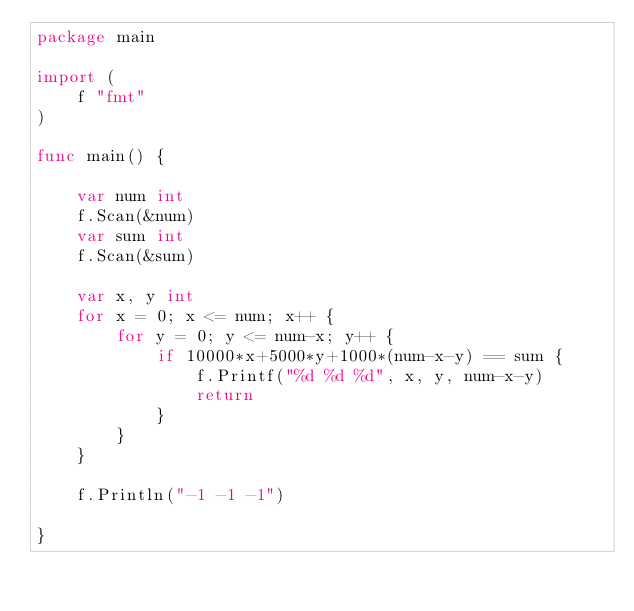Convert code to text. <code><loc_0><loc_0><loc_500><loc_500><_Go_>package main

import (
	f "fmt"
)

func main() {

	var num int
	f.Scan(&num)
	var sum int
	f.Scan(&sum)

	var x, y int
	for x = 0; x <= num; x++ {
		for y = 0; y <= num-x; y++ {
			if 10000*x+5000*y+1000*(num-x-y) == sum {
				f.Printf("%d %d %d", x, y, num-x-y)
				return
			}
		}
	}

	f.Println("-1 -1 -1")

}
</code> 